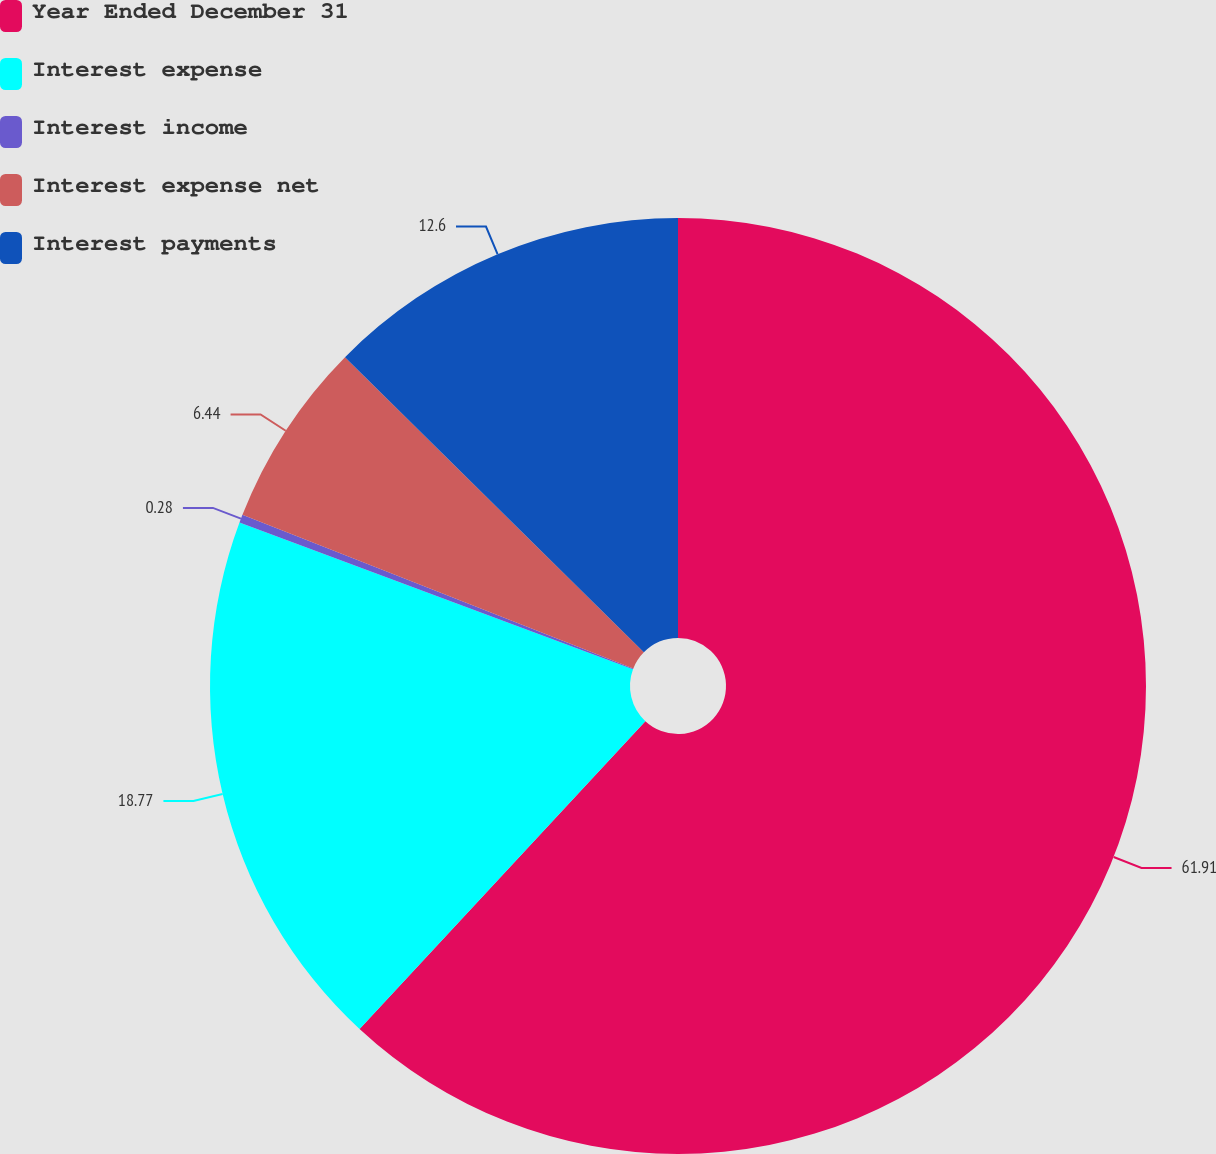Convert chart to OTSL. <chart><loc_0><loc_0><loc_500><loc_500><pie_chart><fcel>Year Ended December 31<fcel>Interest expense<fcel>Interest income<fcel>Interest expense net<fcel>Interest payments<nl><fcel>61.91%<fcel>18.77%<fcel>0.28%<fcel>6.44%<fcel>12.6%<nl></chart> 